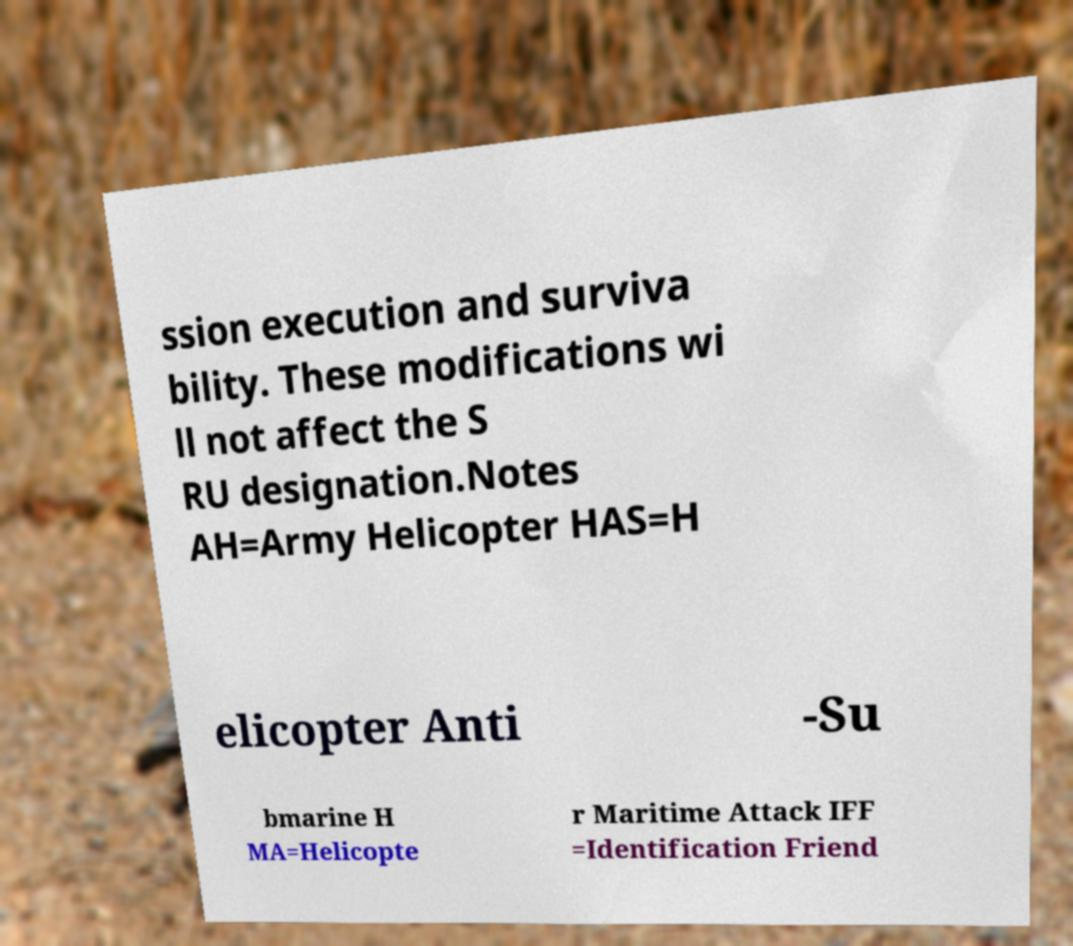Could you extract and type out the text from this image? ssion execution and surviva bility. These modifications wi ll not affect the S RU designation.Notes AH=Army Helicopter HAS=H elicopter Anti -Su bmarine H MA=Helicopte r Maritime Attack IFF =Identification Friend 